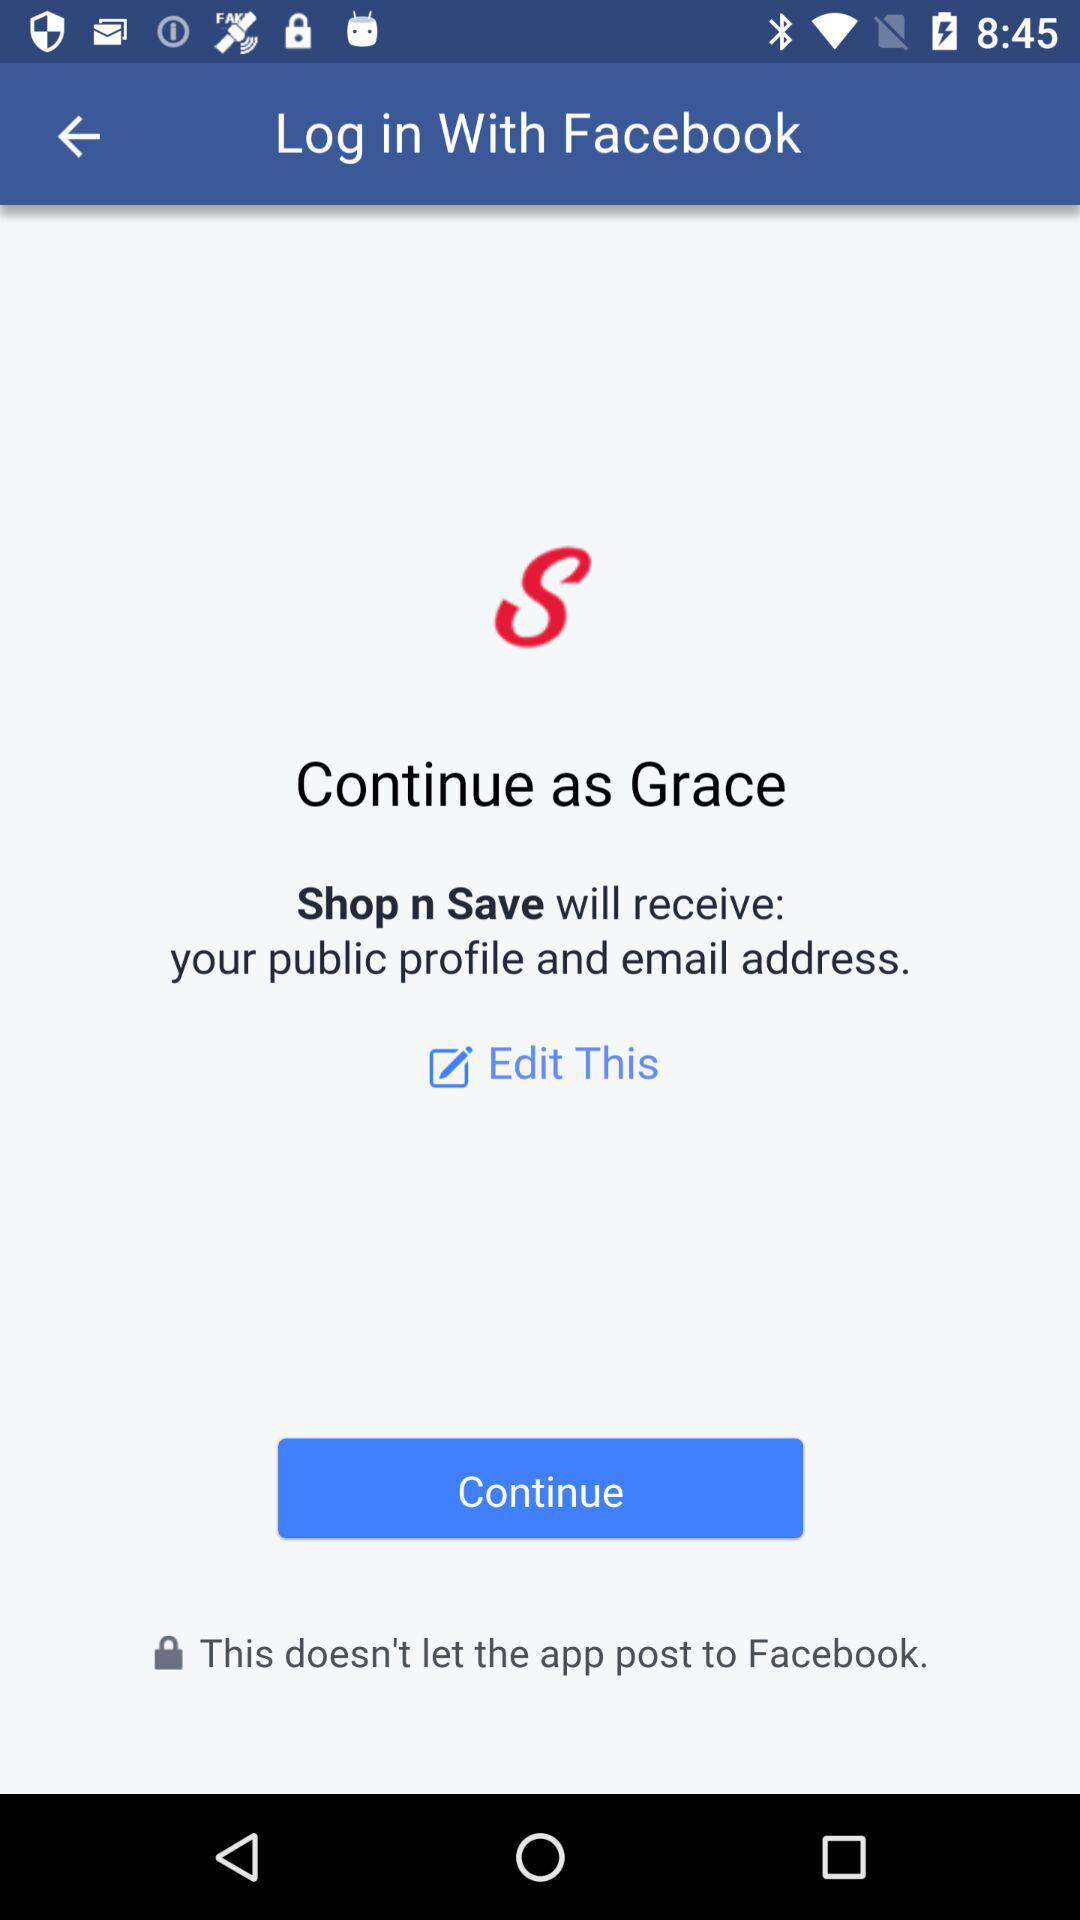What application is asking for permission? The application "Shop n Save" is asking for permission. 